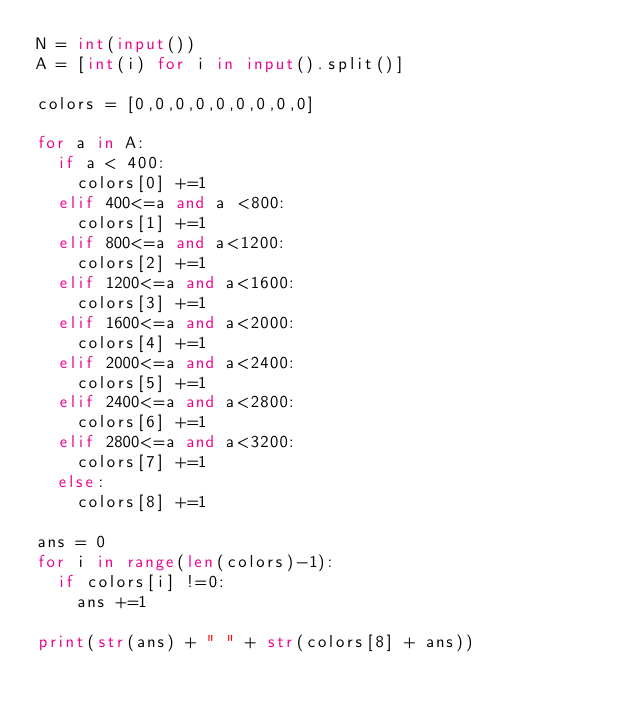Convert code to text. <code><loc_0><loc_0><loc_500><loc_500><_Python_>N = int(input())
A = [int(i) for i in input().split()]

colors = [0,0,0,0,0,0,0,0,0]

for a in A:
  if a < 400:
    colors[0] +=1
  elif 400<=a and a <800:
    colors[1] +=1
  elif 800<=a and a<1200:
    colors[2] +=1
  elif 1200<=a and a<1600:
    colors[3] +=1
  elif 1600<=a and a<2000:
    colors[4] +=1
  elif 2000<=a and a<2400:
    colors[5] +=1
  elif 2400<=a and a<2800:
    colors[6] +=1
  elif 2800<=a and a<3200:
    colors[7] +=1
  else:
    colors[8] +=1

ans = 0
for i in range(len(colors)-1):
  if colors[i] !=0:
    ans +=1

print(str(ans) + " " + str(colors[8] + ans))
</code> 